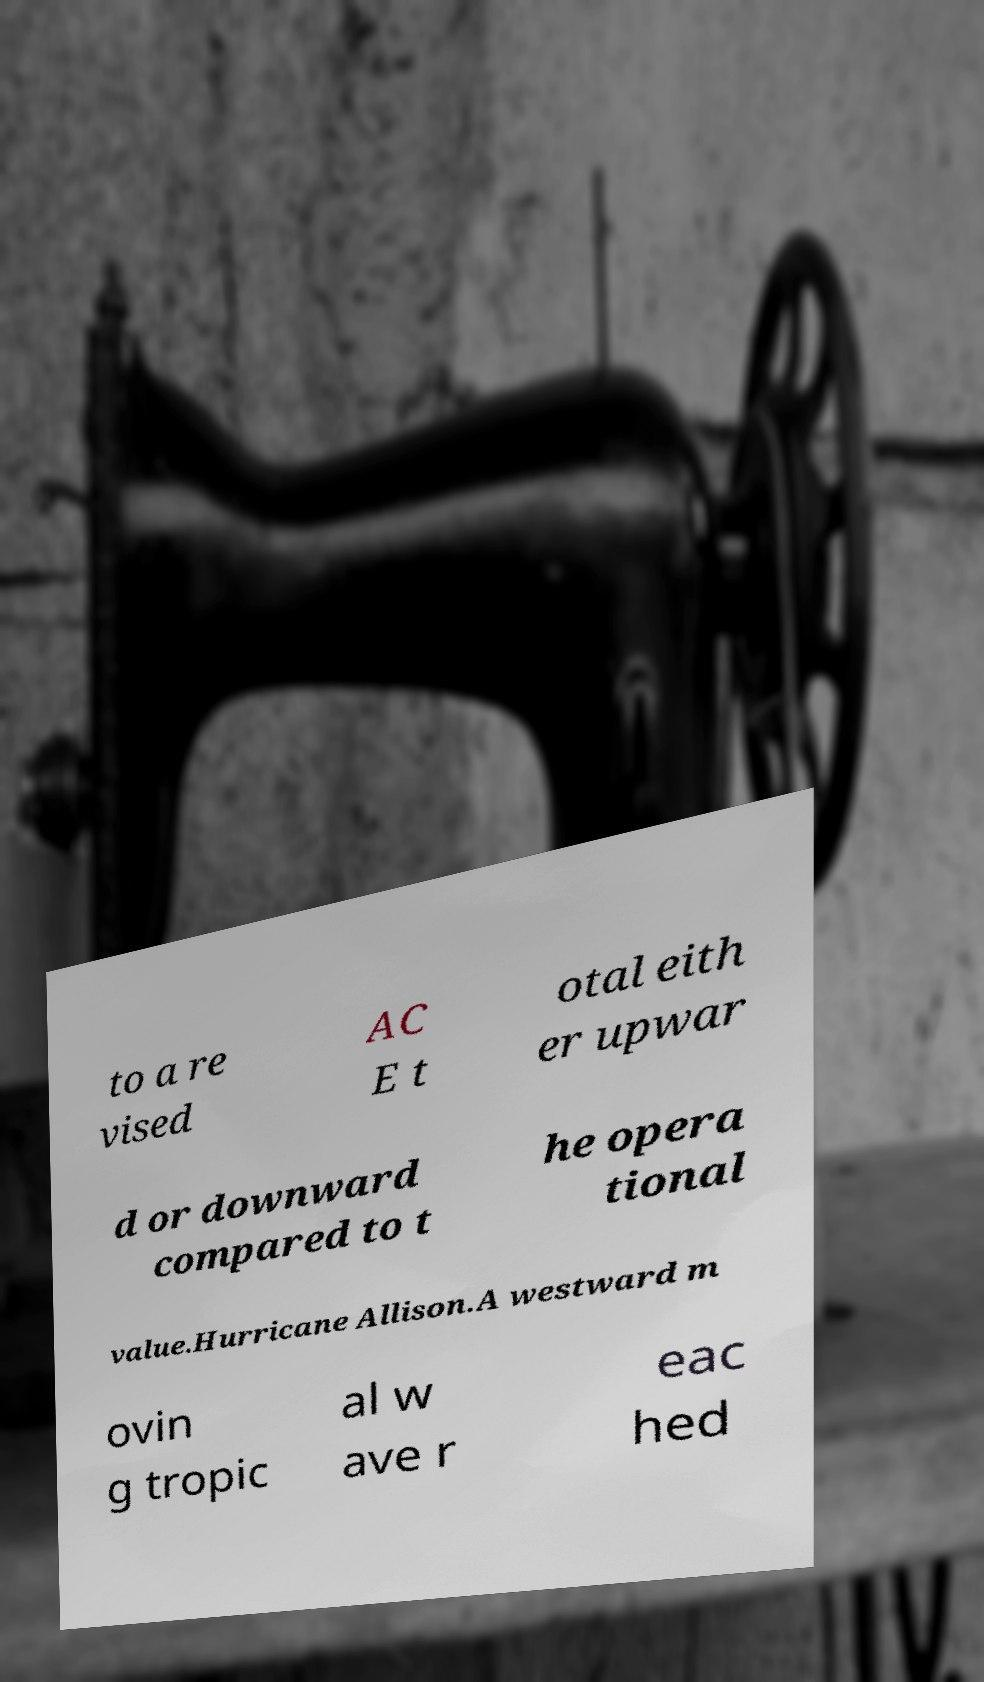What messages or text are displayed in this image? I need them in a readable, typed format. to a re vised AC E t otal eith er upwar d or downward compared to t he opera tional value.Hurricane Allison.A westward m ovin g tropic al w ave r eac hed 